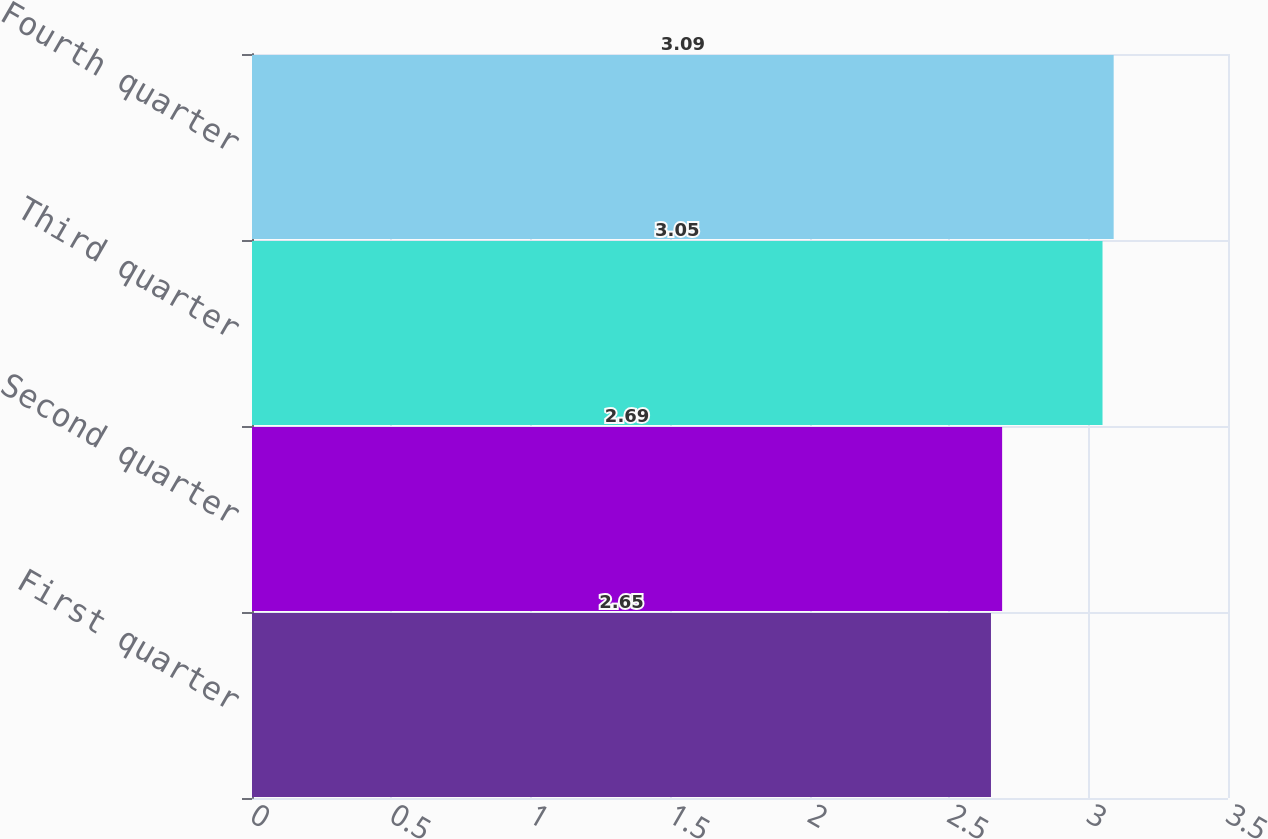Convert chart to OTSL. <chart><loc_0><loc_0><loc_500><loc_500><bar_chart><fcel>First quarter<fcel>Second quarter<fcel>Third quarter<fcel>Fourth quarter<nl><fcel>2.65<fcel>2.69<fcel>3.05<fcel>3.09<nl></chart> 